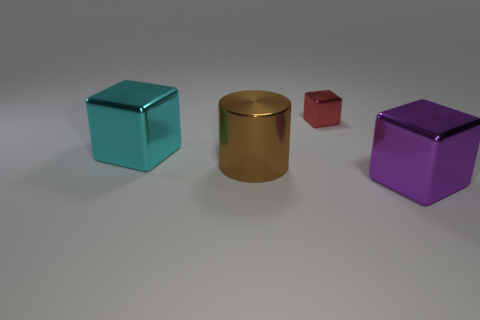What number of things are either cubes that are in front of the big brown cylinder or shiny cubes that are in front of the large cyan block?
Provide a succinct answer. 1. Is the size of the purple metallic cube the same as the brown metal object?
Your answer should be compact. Yes. Are there more large gray metallic spheres than large metallic cylinders?
Your answer should be very brief. No. What number of other objects are the same color as the tiny thing?
Ensure brevity in your answer.  0. How many things are brown metallic blocks or large things?
Your response must be concise. 3. Is the shape of the metallic thing behind the cyan shiny cube the same as  the large cyan shiny object?
Provide a succinct answer. Yes. The big metallic cube behind the large metal thing in front of the cylinder is what color?
Make the answer very short. Cyan. Is the number of small red objects less than the number of big metallic objects?
Ensure brevity in your answer.  Yes. Is there a small red cylinder made of the same material as the large purple object?
Your answer should be very brief. No. There is a brown thing; does it have the same shape as the object in front of the large brown cylinder?
Your answer should be compact. No. 